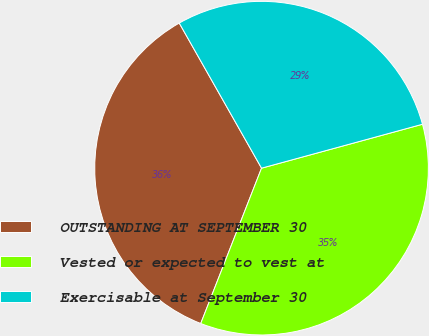Convert chart. <chart><loc_0><loc_0><loc_500><loc_500><pie_chart><fcel>OUTSTANDING AT SEPTEMBER 30<fcel>Vested or expected to vest at<fcel>Exercisable at September 30<nl><fcel>35.85%<fcel>35.18%<fcel>28.97%<nl></chart> 